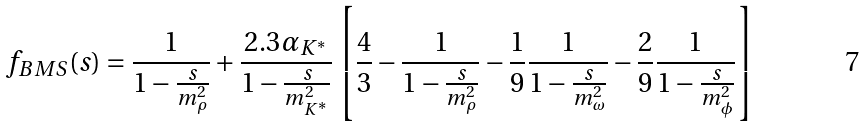Convert formula to latex. <formula><loc_0><loc_0><loc_500><loc_500>f _ { B M S } ( s ) = \frac { 1 } { 1 - \frac { s } { m ^ { 2 } _ { \rho } } } + \frac { 2 . 3 \alpha _ { K ^ { * } } } { 1 - \frac { s } { m ^ { 2 } _ { K ^ { * } } } } \left [ \frac { 4 } { 3 } - \frac { 1 } { 1 - \frac { s } { m ^ { 2 } _ { \rho } } } - \frac { 1 } { 9 } \frac { 1 } { 1 - \frac { s } { m ^ { 2 } _ { \omega } } } - \frac { 2 } { 9 } \frac { 1 } { 1 - \frac { s } { m ^ { 2 } _ { \phi } } } \right ]</formula> 